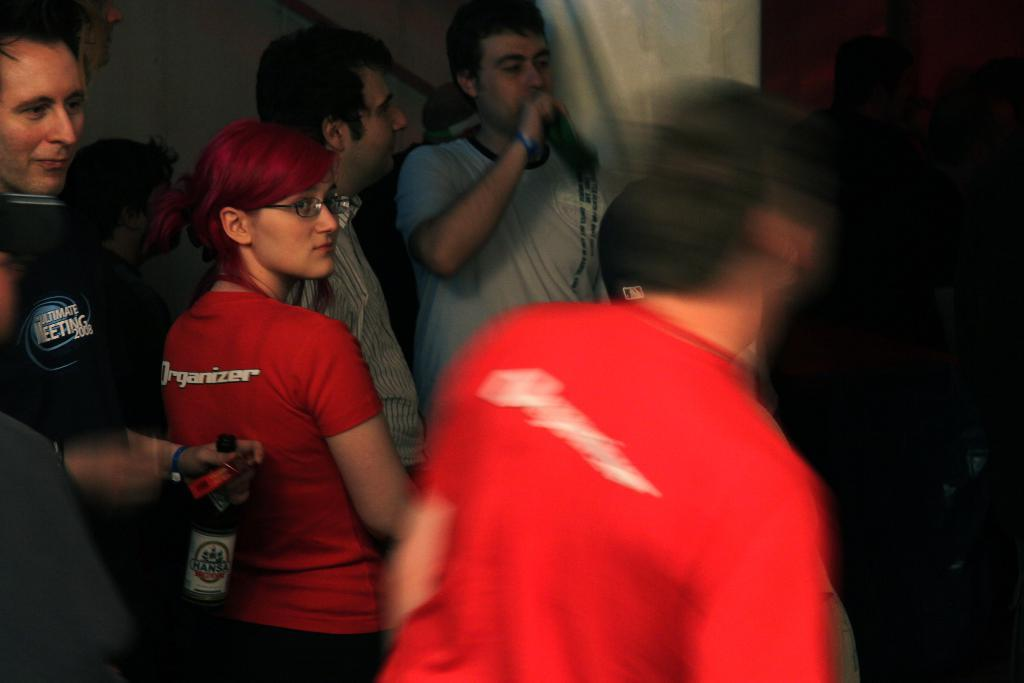What is happening in the image? There are people standing in the image, and one man is holding a microphone. What is the man with the microphone doing? The man holding the microphone is talking. What is another person holding in the image? One person is holding a wine bottle. Can you see the person's ear in the image? There is no specific mention of a person's ear in the image, so it cannot be confirmed whether it is visible or not. 